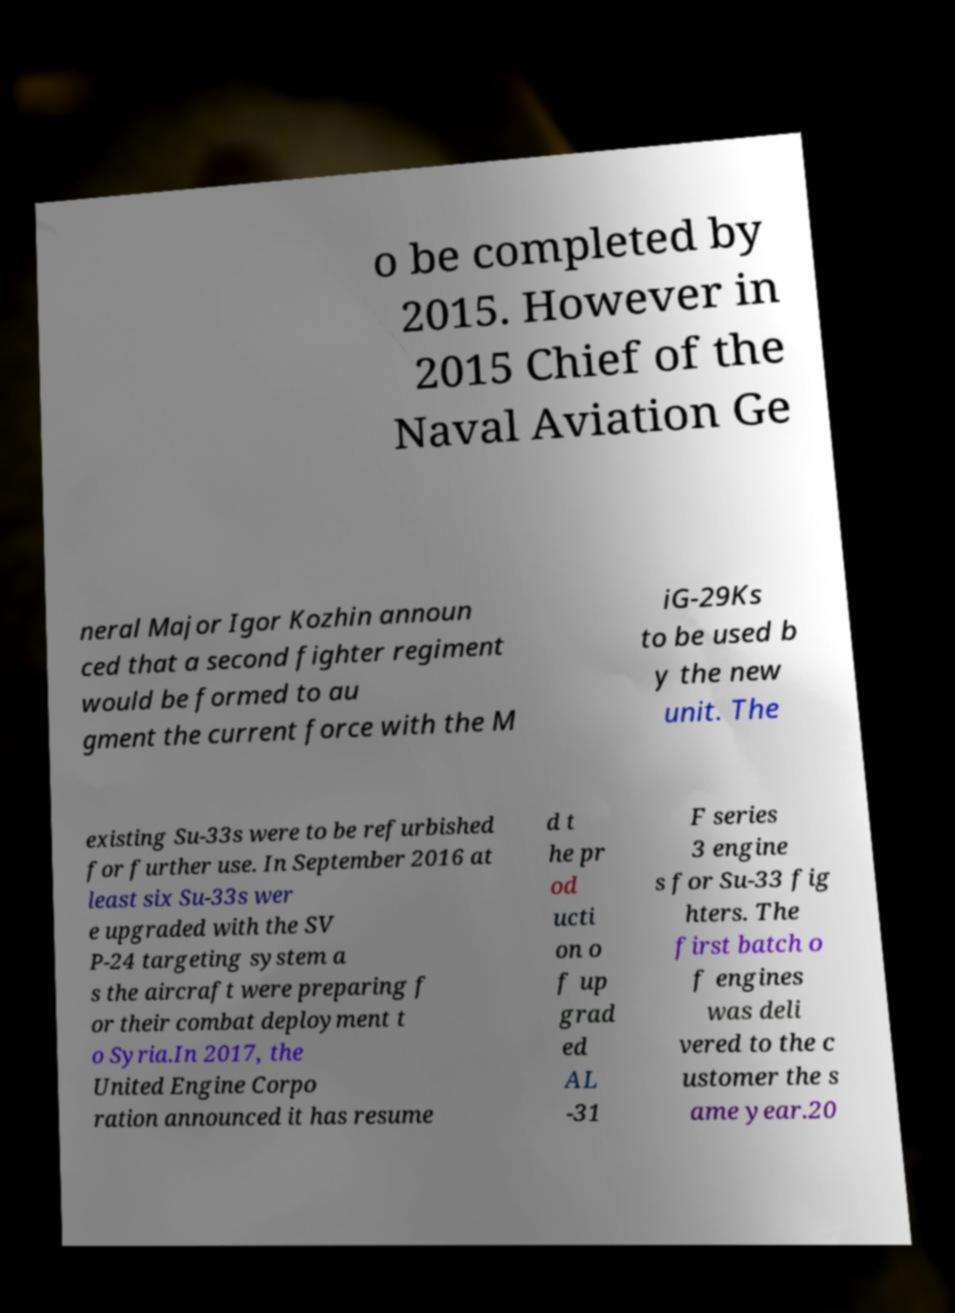For documentation purposes, I need the text within this image transcribed. Could you provide that? o be completed by 2015. However in 2015 Chief of the Naval Aviation Ge neral Major Igor Kozhin announ ced that a second fighter regiment would be formed to au gment the current force with the M iG-29Ks to be used b y the new unit. The existing Su-33s were to be refurbished for further use. In September 2016 at least six Su-33s wer e upgraded with the SV P-24 targeting system a s the aircraft were preparing f or their combat deployment t o Syria.In 2017, the United Engine Corpo ration announced it has resume d t he pr od ucti on o f up grad ed AL -31 F series 3 engine s for Su-33 fig hters. The first batch o f engines was deli vered to the c ustomer the s ame year.20 